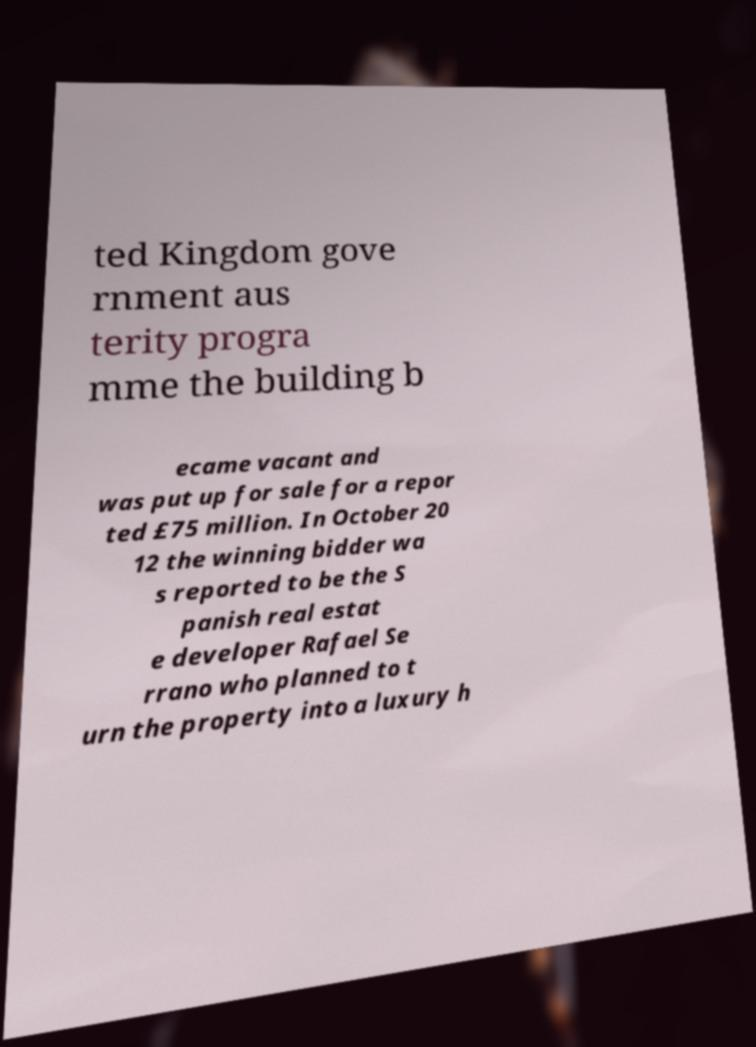Could you assist in decoding the text presented in this image and type it out clearly? ted Kingdom gove rnment aus terity progra mme the building b ecame vacant and was put up for sale for a repor ted £75 million. In October 20 12 the winning bidder wa s reported to be the S panish real estat e developer Rafael Se rrano who planned to t urn the property into a luxury h 